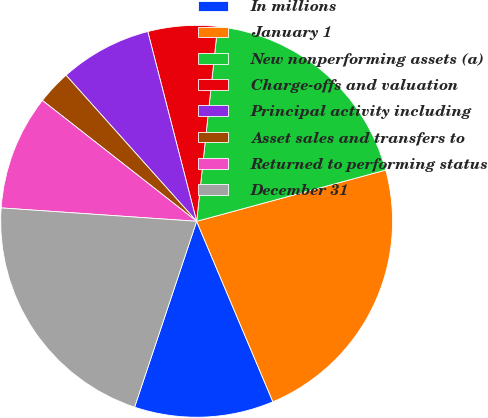Convert chart. <chart><loc_0><loc_0><loc_500><loc_500><pie_chart><fcel>In millions<fcel>January 1<fcel>New nonperforming assets (a)<fcel>Charge-offs and valuation<fcel>Principal activity including<fcel>Asset sales and transfers to<fcel>Returned to performing status<fcel>December 31<nl><fcel>11.49%<fcel>22.85%<fcel>19.08%<fcel>5.72%<fcel>7.6%<fcel>2.81%<fcel>9.49%<fcel>20.96%<nl></chart> 